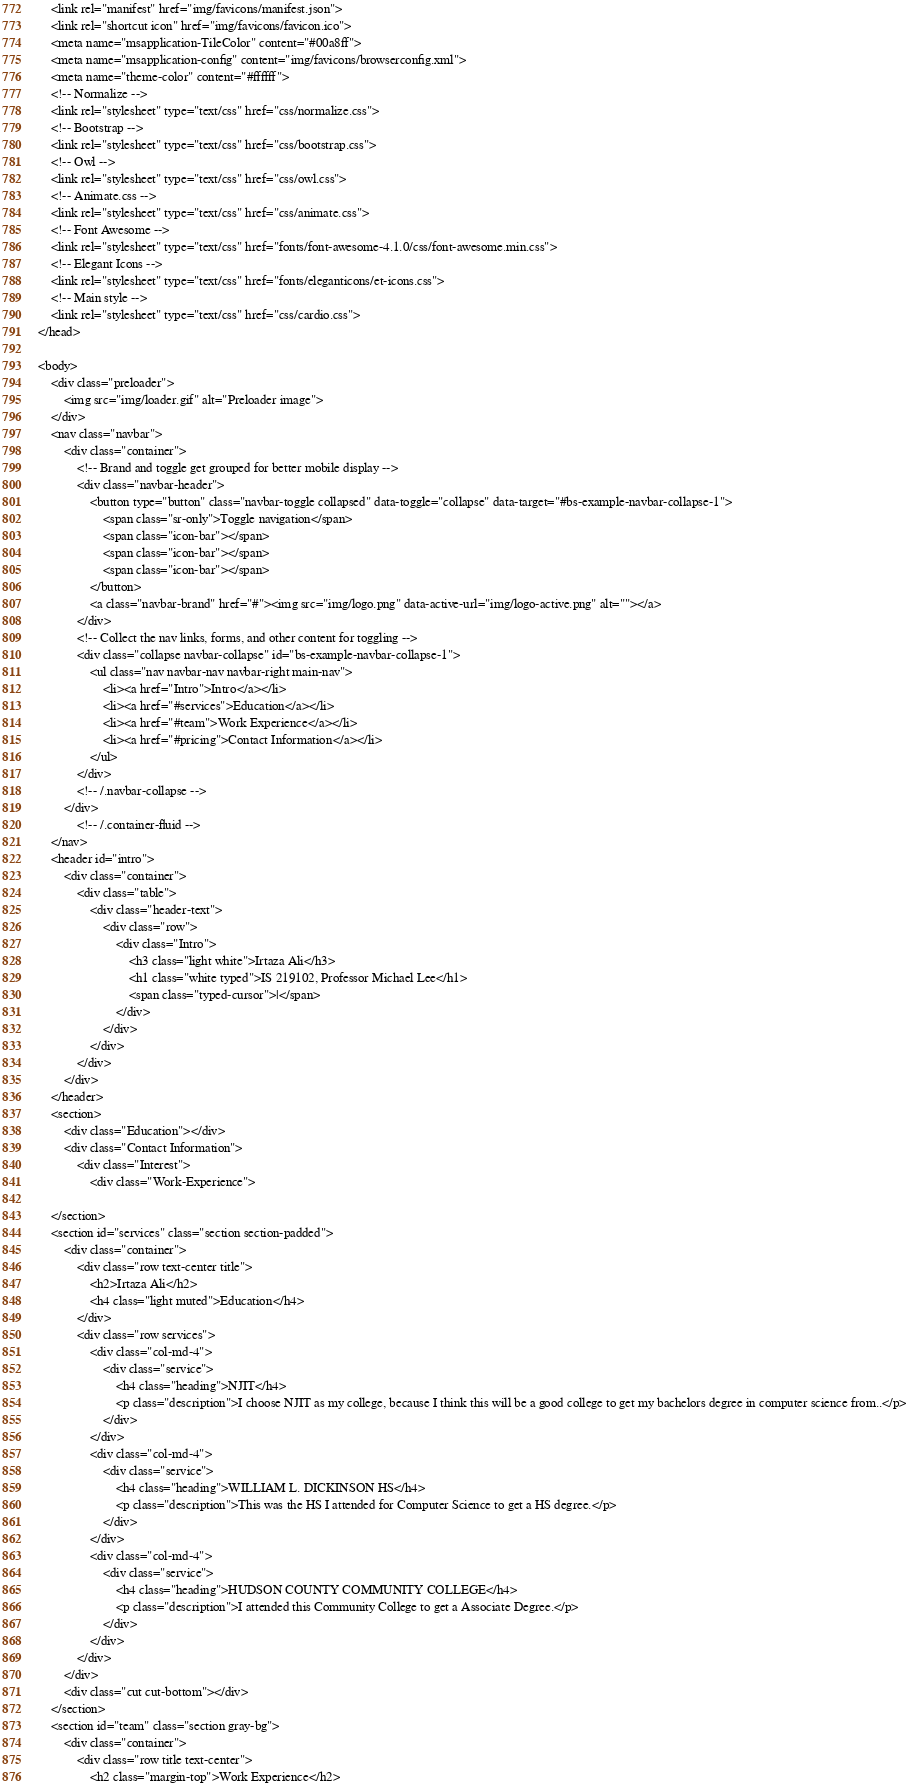<code> <loc_0><loc_0><loc_500><loc_500><_PHP_>	<link rel="manifest" href="img/favicons/manifest.json">
	<link rel="shortcut icon" href="img/favicons/favicon.ico">
	<meta name="msapplication-TileColor" content="#00a8ff">
	<meta name="msapplication-config" content="img/favicons/browserconfig.xml">
	<meta name="theme-color" content="#ffffff">
	<!-- Normalize -->
	<link rel="stylesheet" type="text/css" href="css/normalize.css">
	<!-- Bootstrap -->
	<link rel="stylesheet" type="text/css" href="css/bootstrap.css">
	<!-- Owl -->
	<link rel="stylesheet" type="text/css" href="css/owl.css">
	<!-- Animate.css -->
	<link rel="stylesheet" type="text/css" href="css/animate.css">
	<!-- Font Awesome -->
	<link rel="stylesheet" type="text/css" href="fonts/font-awesome-4.1.0/css/font-awesome.min.css">
	<!-- Elegant Icons -->
	<link rel="stylesheet" type="text/css" href="fonts/eleganticons/et-icons.css">
	<!-- Main style -->
	<link rel="stylesheet" type="text/css" href="css/cardio.css">
</head>

<body>
	<div class="preloader">
		<img src="img/loader.gif" alt="Preloader image">
	</div>
	<nav class="navbar">
		<div class="container">
			<!-- Brand and toggle get grouped for better mobile display -->
			<div class="navbar-header">
				<button type="button" class="navbar-toggle collapsed" data-toggle="collapse" data-target="#bs-example-navbar-collapse-1">
					<span class="sr-only">Toggle navigation</span>
					<span class="icon-bar"></span>
					<span class="icon-bar"></span>
					<span class="icon-bar"></span>
				</button>
				<a class="navbar-brand" href="#"><img src="img/logo.png" data-active-url="img/logo-active.png" alt=""></a>
			</div>
			<!-- Collect the nav links, forms, and other content for toggling -->
			<div class="collapse navbar-collapse" id="bs-example-navbar-collapse-1">
				<ul class="nav navbar-nav navbar-right main-nav">
					<li><a href="Intro">Intro</a></li>
					<li><a href="#services">Education</a></li>
					<li><a href="#team">Work Experience</a></li>
					<li><a href="#pricing">Contact Information</a></li>
				</ul>
			</div>
			<!-- /.navbar-collapse -->
		</div>
			<!-- /.container-fluid -->
	</nav>
	<header id="intro">
		<div class="container">
			<div class="table">
				<div class="header-text">
					<div class="row">
						<div class="Intro">
							<h3 class="light white">Irtaza Ali</h3>
							<h1 class="white typed">IS 219102, Professor Michael Lee</h1>
							<span class="typed-cursor">|</span>
						</div>
					</div>
				</div>
			</div>
		</div>
	</header>
	<section>
		<div class="Education"></div>
		<div class="Contact Information">
			<div class="Interest">
				<div class="Work-Experience">
							
	</section>
	<section id="services" class="section section-padded">
		<div class="container">
			<div class="row text-center title">
				<h2>Irtaza Ali</h2>
				<h4 class="light muted">Education</h4>
			</div>
			<div class="row services">
				<div class="col-md-4">
					<div class="service">
						<h4 class="heading">NJIT</h4>
						<p class="description">I choose NJIT as my college, because I think this will be a good college to get my bachelors degree in computer science from..</p>
					</div>
				</div>
				<div class="col-md-4">
					<div class="service">
						<h4 class="heading">WILLIAM L. DICKINSON HS</h4>
						<p class="description">This was the HS I attended for Computer Science to get a HS degree.</p>
					</div>
				</div>
				<div class="col-md-4">
					<div class="service">
						<h4 class="heading">HUDSON COUNTY COMMUNITY COLLEGE</h4>
						<p class="description">I attended this Community College to get a Associate Degree.</p>
					</div>
				</div>
			</div>
		</div>
		<div class="cut cut-bottom"></div>
	</section>
	<section id="team" class="section gray-bg">
		<div class="container">
			<div class="row title text-center">
				<h2 class="margin-top">Work Experience</h2></code> 